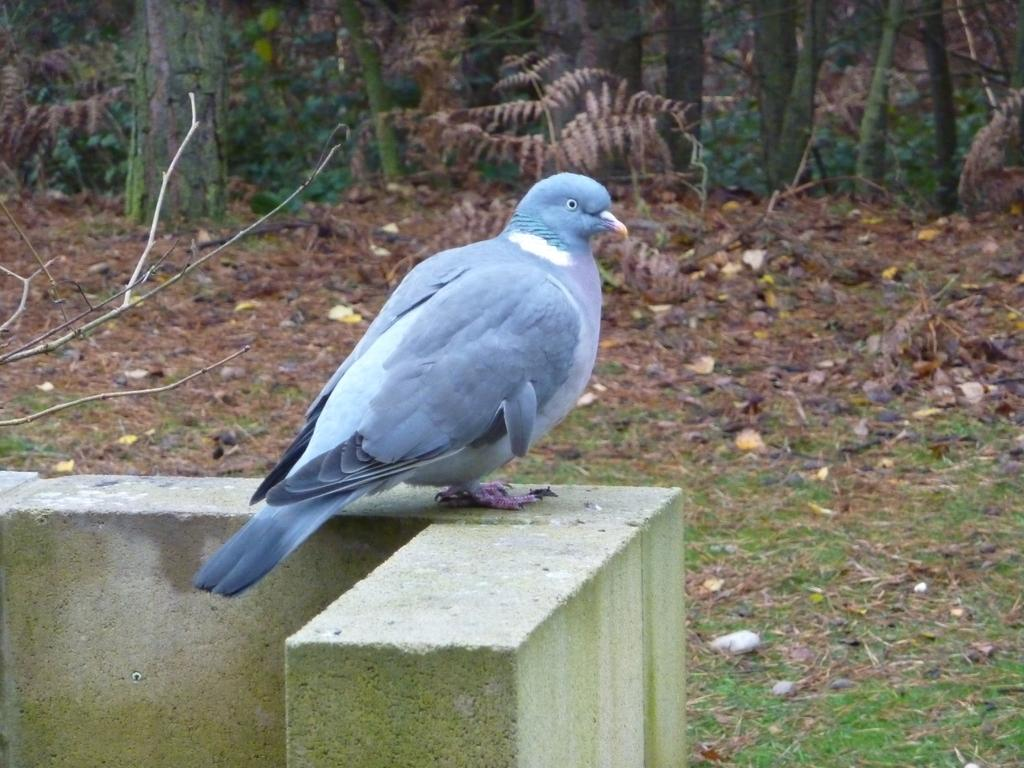What is on the concrete fence in the image? There is a bird on the concrete fence in the image. What type of natural debris can be seen in the image? There are dry leaves in the image. What type of objects are present on the surface in the image? There are stones and branches on the surface in the image. What type of vegetation is visible in the image? There are trees visible in the image. What type of pot is the farmer using to water the trees in the image? There is no farmer or pot present in the image. What route is the bird taking to fly to the next tree in the image? The image does not show the bird flying or taking a specific route to another tree. 